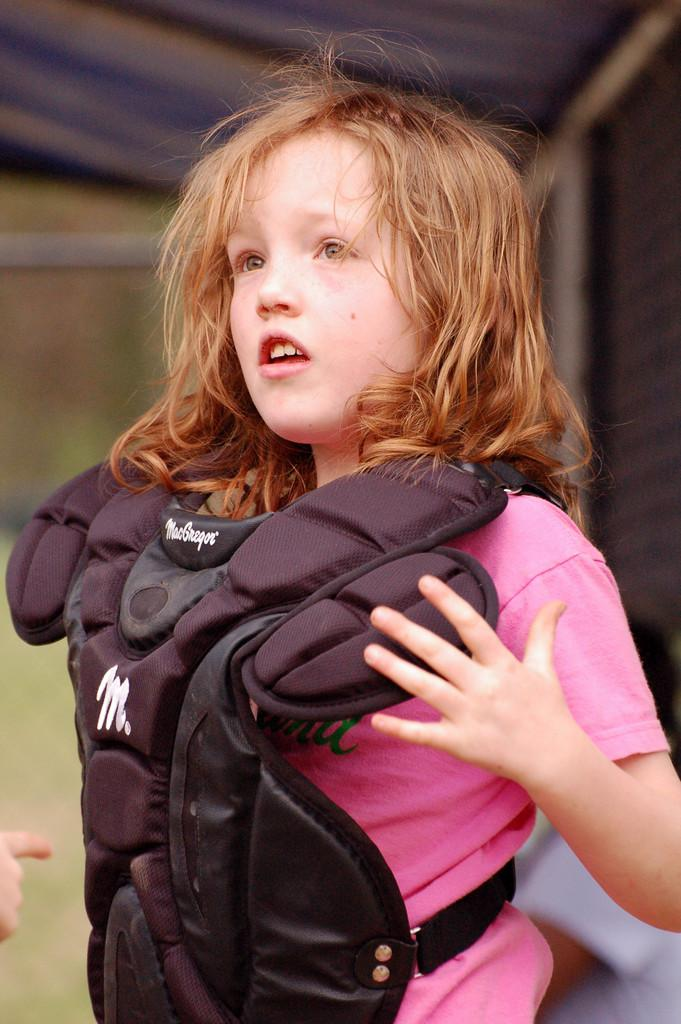What is the girl in the image wearing? The girl is wearing a jacket and a pink color t-shirt. What color is the girl's jacket? The jacket is black in color. What is the position of the woman in the image? The woman is seated in the image. Can you describe the girl's clothing in more detail? The girl is wearing a black jacket and a pink t-shirt. What type of plastic material is the girl holding in the image? There is no plastic material visible in the image. Can you tell me the story behind the girl's outfit in the image? The image does not provide any information about the story behind the girl's outfit. 